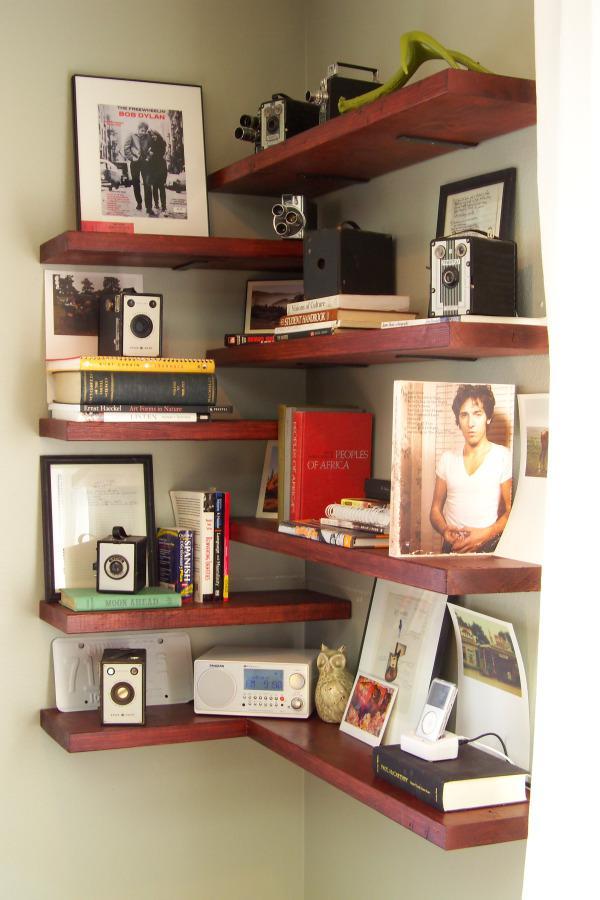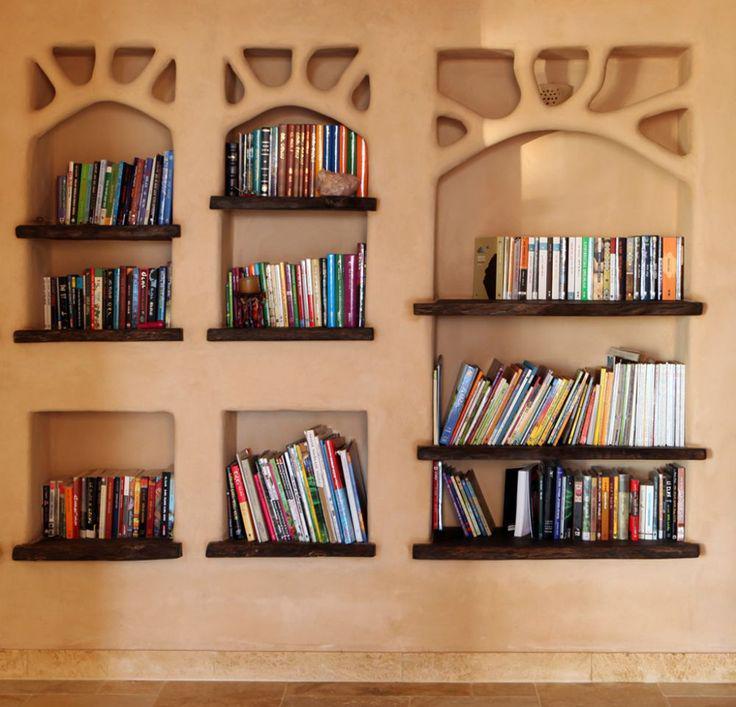The first image is the image on the left, the second image is the image on the right. Given the left and right images, does the statement "In one image, small shelves attached directly to the wall wrap around a corner." hold true? Answer yes or no. Yes. The first image is the image on the left, the second image is the image on the right. Considering the images on both sides, is "An image shows a hanging corner shelf style without back or sides." valid? Answer yes or no. Yes. 